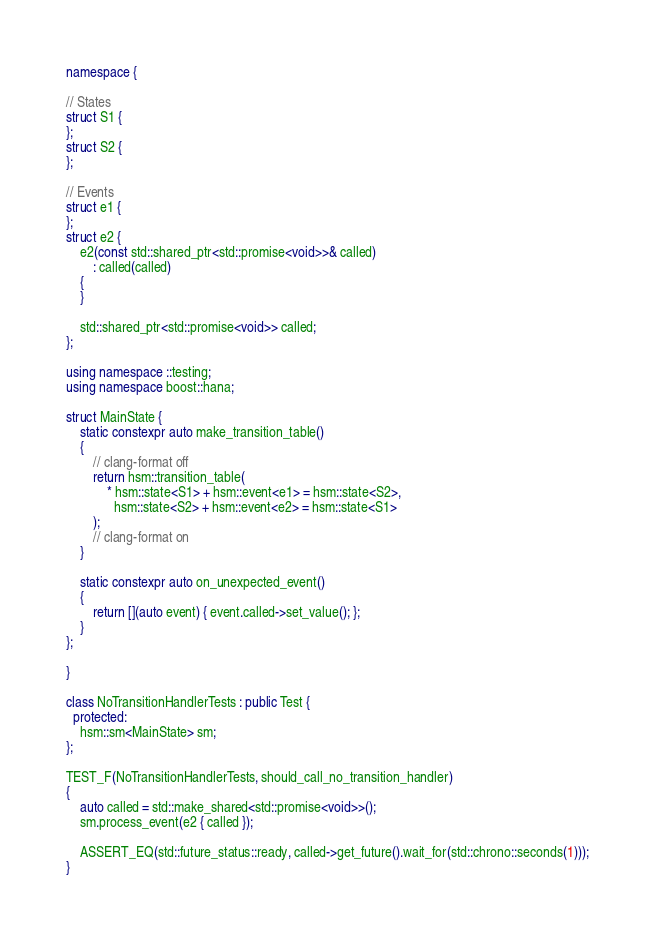<code> <loc_0><loc_0><loc_500><loc_500><_C++_>namespace {

// States
struct S1 {
};
struct S2 {
};

// Events
struct e1 {
};
struct e2 {
    e2(const std::shared_ptr<std::promise<void>>& called)
        : called(called)
    {
    }

    std::shared_ptr<std::promise<void>> called;
};

using namespace ::testing;
using namespace boost::hana;

struct MainState {
    static constexpr auto make_transition_table()
    {
        // clang-format off
        return hsm::transition_table(
            * hsm::state<S1> + hsm::event<e1> = hsm::state<S2>,
              hsm::state<S2> + hsm::event<e2> = hsm::state<S1>
        );
        // clang-format on
    }

    static constexpr auto on_unexpected_event()
    {
        return [](auto event) { event.called->set_value(); };
    }
};

}

class NoTransitionHandlerTests : public Test {
  protected:
    hsm::sm<MainState> sm;
};

TEST_F(NoTransitionHandlerTests, should_call_no_transition_handler)
{
    auto called = std::make_shared<std::promise<void>>();
    sm.process_event(e2 { called });

    ASSERT_EQ(std::future_status::ready, called->get_future().wait_for(std::chrono::seconds(1)));
}</code> 